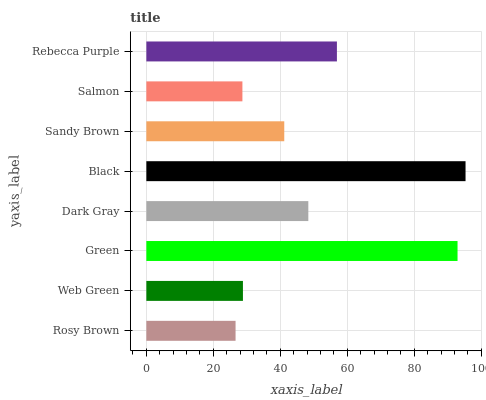Is Rosy Brown the minimum?
Answer yes or no. Yes. Is Black the maximum?
Answer yes or no. Yes. Is Web Green the minimum?
Answer yes or no. No. Is Web Green the maximum?
Answer yes or no. No. Is Web Green greater than Rosy Brown?
Answer yes or no. Yes. Is Rosy Brown less than Web Green?
Answer yes or no. Yes. Is Rosy Brown greater than Web Green?
Answer yes or no. No. Is Web Green less than Rosy Brown?
Answer yes or no. No. Is Dark Gray the high median?
Answer yes or no. Yes. Is Sandy Brown the low median?
Answer yes or no. Yes. Is Rebecca Purple the high median?
Answer yes or no. No. Is Rebecca Purple the low median?
Answer yes or no. No. 